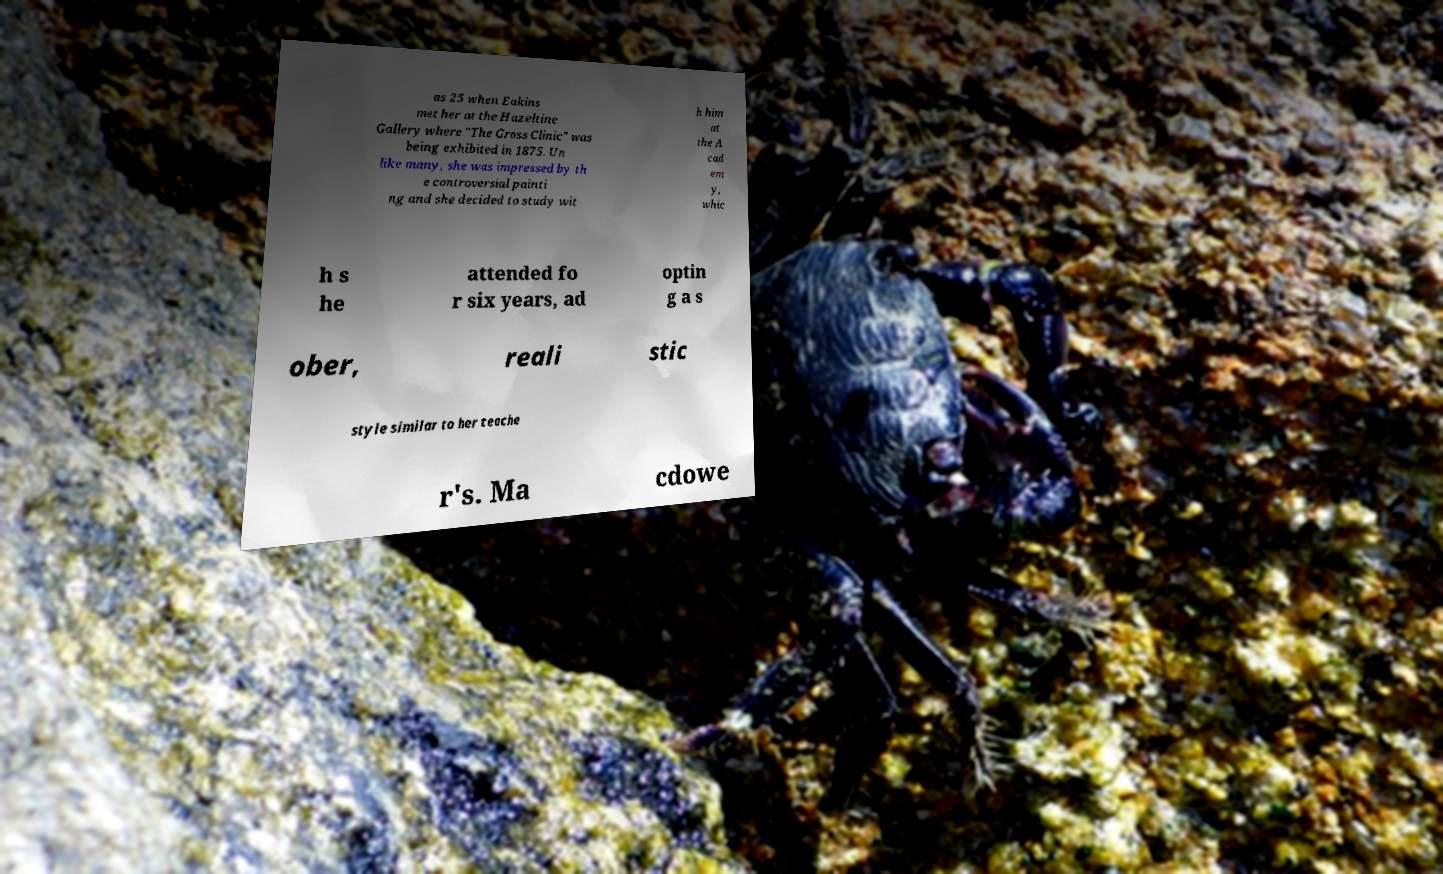Can you read and provide the text displayed in the image?This photo seems to have some interesting text. Can you extract and type it out for me? as 25 when Eakins met her at the Hazeltine Gallery where "The Gross Clinic" was being exhibited in 1875. Un like many, she was impressed by th e controversial painti ng and she decided to study wit h him at the A cad em y, whic h s he attended fo r six years, ad optin g a s ober, reali stic style similar to her teache r's. Ma cdowe 